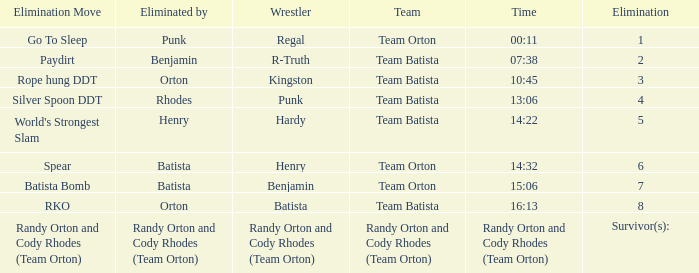Which Elimination Move is listed at Elimination 8 for Team Batista? RKO. Give me the full table as a dictionary. {'header': ['Elimination Move', 'Eliminated by', 'Wrestler', 'Team', 'Time', 'Elimination'], 'rows': [['Go To Sleep', 'Punk', 'Regal', 'Team Orton', '00:11', '1'], ['Paydirt', 'Benjamin', 'R-Truth', 'Team Batista', '07:38', '2'], ['Rope hung DDT', 'Orton', 'Kingston', 'Team Batista', '10:45', '3'], ['Silver Spoon DDT', 'Rhodes', 'Punk', 'Team Batista', '13:06', '4'], ["World's Strongest Slam", 'Henry', 'Hardy', 'Team Batista', '14:22', '5'], ['Spear', 'Batista', 'Henry', 'Team Orton', '14:32', '6'], ['Batista Bomb', 'Batista', 'Benjamin', 'Team Orton', '15:06', '7'], ['RKO', 'Orton', 'Batista', 'Team Batista', '16:13', '8'], ['Randy Orton and Cody Rhodes (Team Orton)', 'Randy Orton and Cody Rhodes (Team Orton)', 'Randy Orton and Cody Rhodes (Team Orton)', 'Randy Orton and Cody Rhodes (Team Orton)', 'Randy Orton and Cody Rhodes (Team Orton)', 'Survivor(s):']]} 